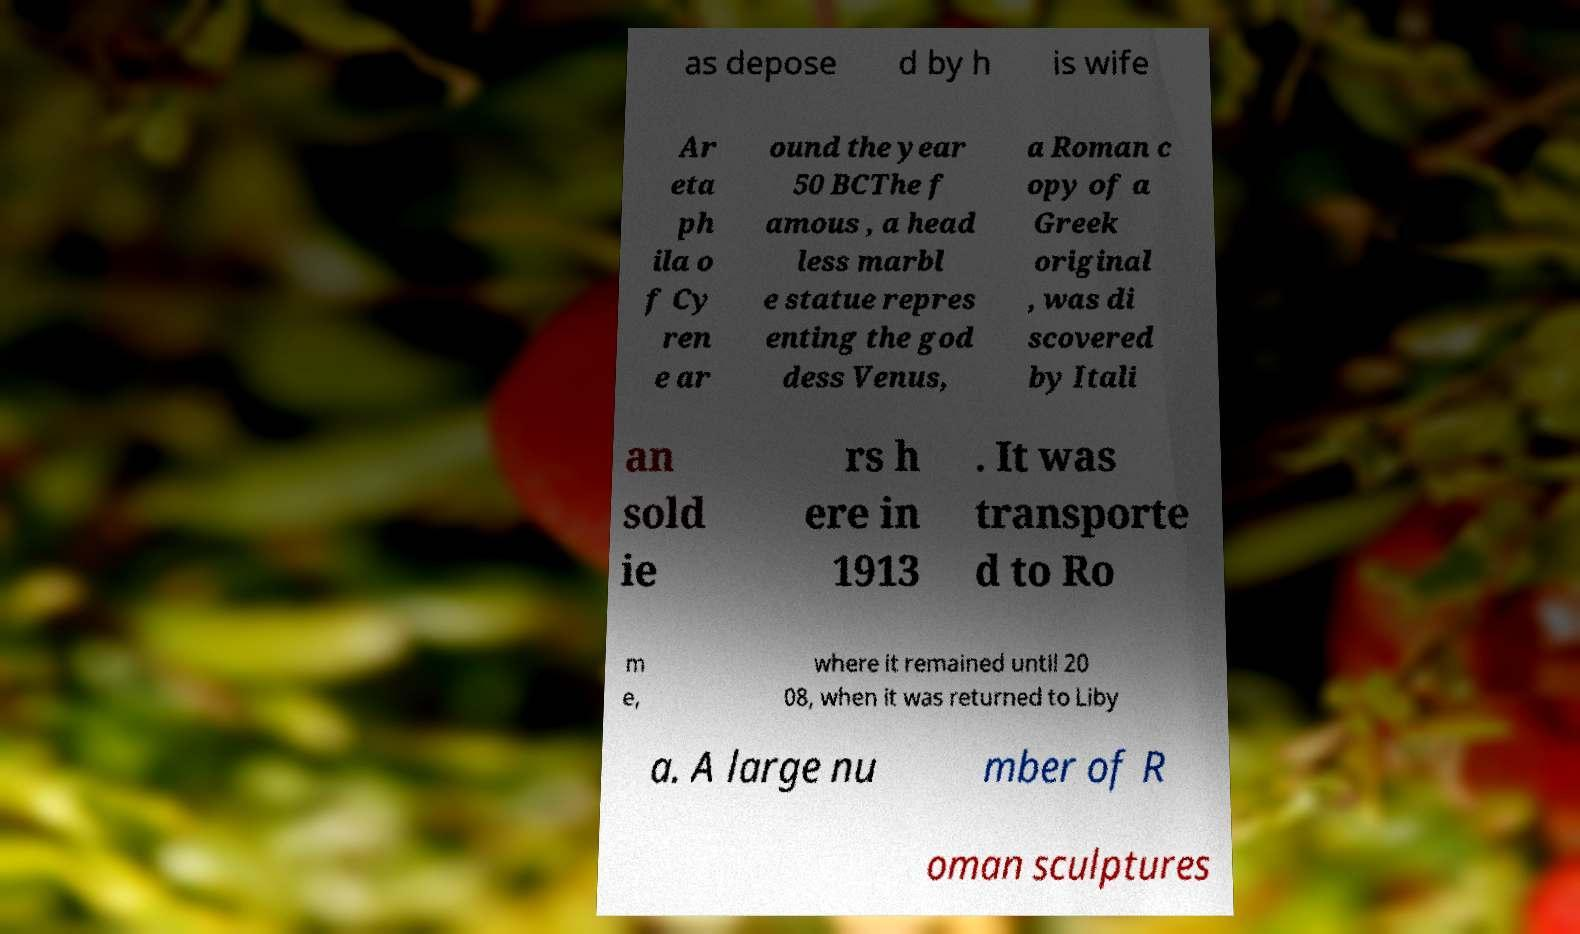Could you extract and type out the text from this image? as depose d by h is wife Ar eta ph ila o f Cy ren e ar ound the year 50 BCThe f amous , a head less marbl e statue repres enting the god dess Venus, a Roman c opy of a Greek original , was di scovered by Itali an sold ie rs h ere in 1913 . It was transporte d to Ro m e, where it remained until 20 08, when it was returned to Liby a. A large nu mber of R oman sculptures 